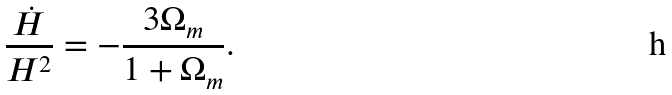Convert formula to latex. <formula><loc_0><loc_0><loc_500><loc_500>\frac { \dot { H } } { H ^ { 2 } } = - \frac { 3 \Omega _ { m } } { 1 + \Omega _ { m } } .</formula> 